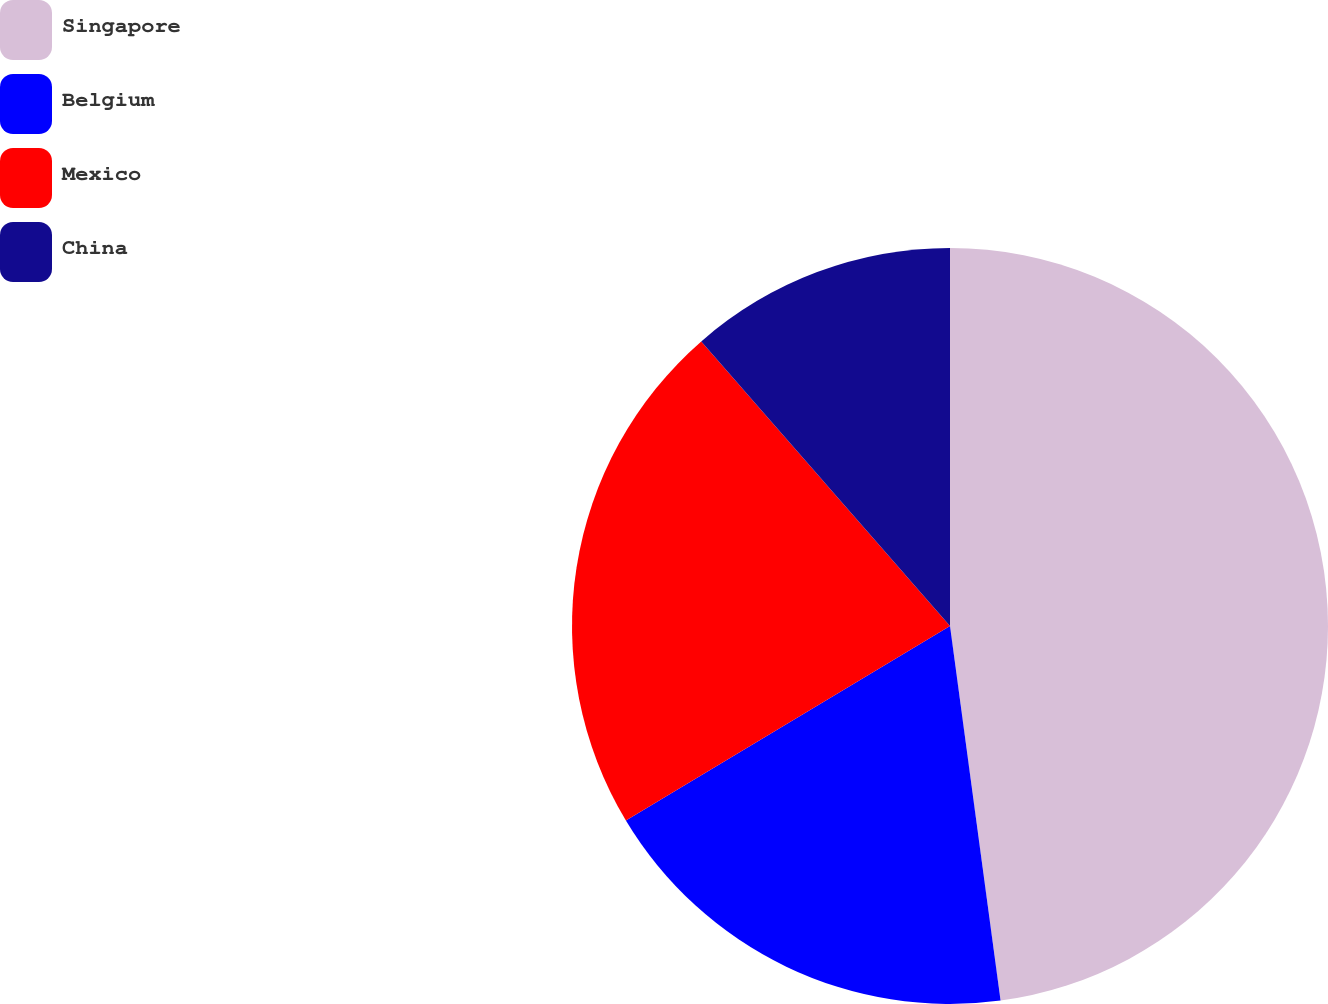Convert chart. <chart><loc_0><loc_0><loc_500><loc_500><pie_chart><fcel>Singapore<fcel>Belgium<fcel>Mexico<fcel>China<nl><fcel>47.86%<fcel>18.53%<fcel>22.17%<fcel>11.43%<nl></chart> 